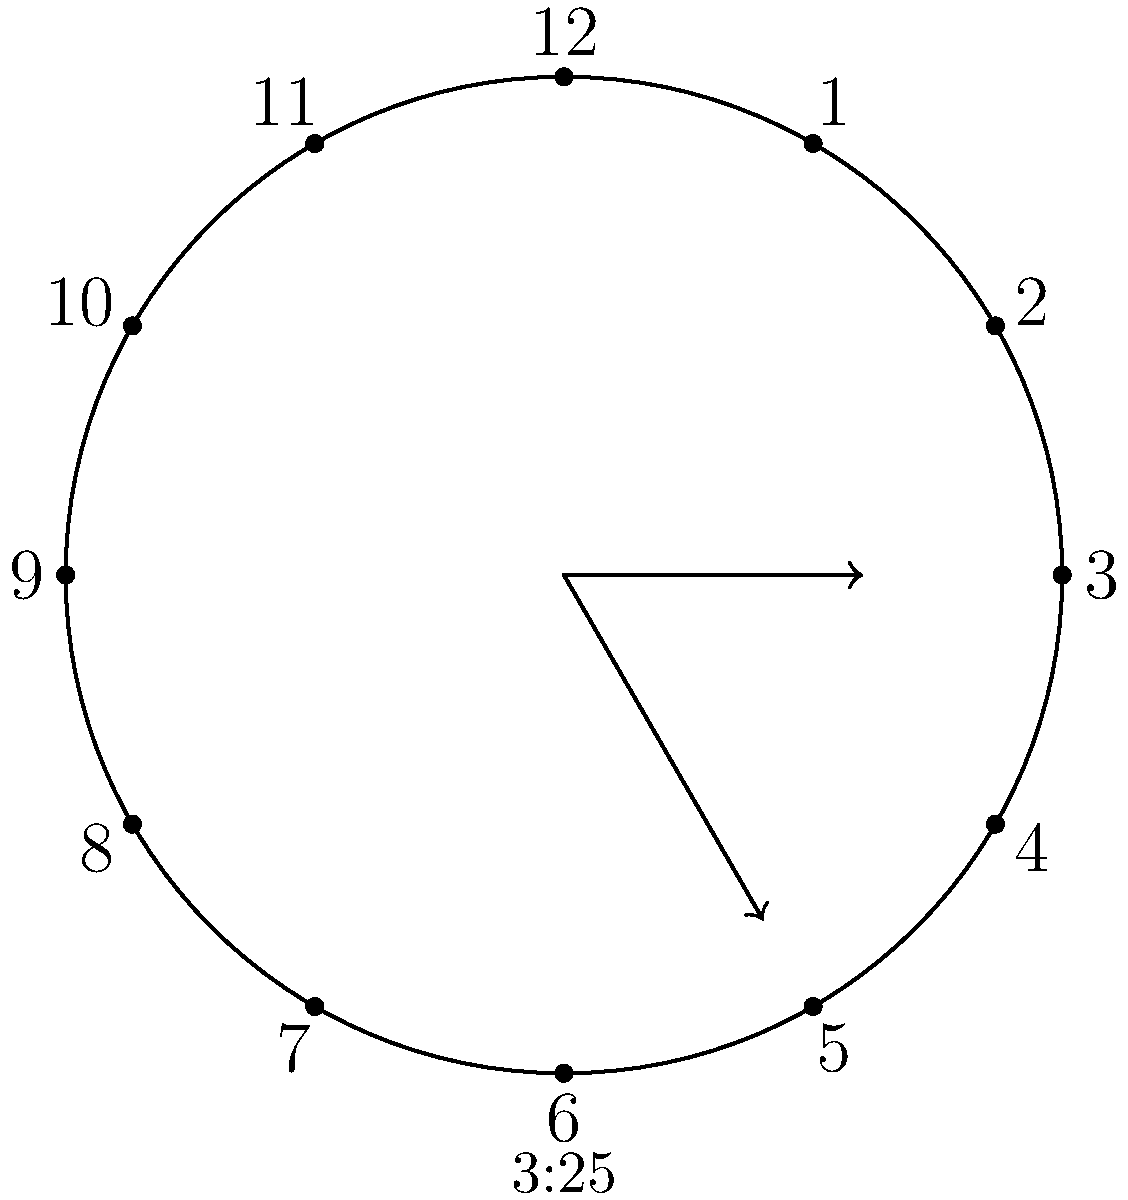In the spirit of DCI Gene Hunt's punctuality, imagine the analog clock in the CID office showing 3:25. What is the smaller angle formed between the hour and minute hands? Let's solve this step-by-step, just like Sam Tyler would approach a case:

1) First, let's calculate the angle made by the hour hand from the 12 o'clock position:
   - In 1 hour, the hour hand rotates 30° (360° ÷ 12)
   - In 3 hours, it rotates 3 × 30° = 90°
   - In 25 minutes, it rotates an additional (25 ÷ 60) × 30° = 12.5°
   - Total angle for hour hand: 90° + 12.5° = 102.5°

2) Now, let's calculate the angle made by the minute hand:
   - In 1 minute, the minute hand rotates 6° (360° ÷ 60)
   - In 25 minutes, it rotates 25 × 6° = 150°

3) The angle between the hands is the absolute difference:
   $|150° - 102.5°| = 47.5°$

4) However, we need the smaller angle. If this angle is greater than 180°, we need to subtract it from 360°:
   47.5° is already the smaller angle, so no further calculation is needed.

Therefore, the smaller angle between the hour and minute hands at 3:25 is 47.5°.
Answer: 47.5° 